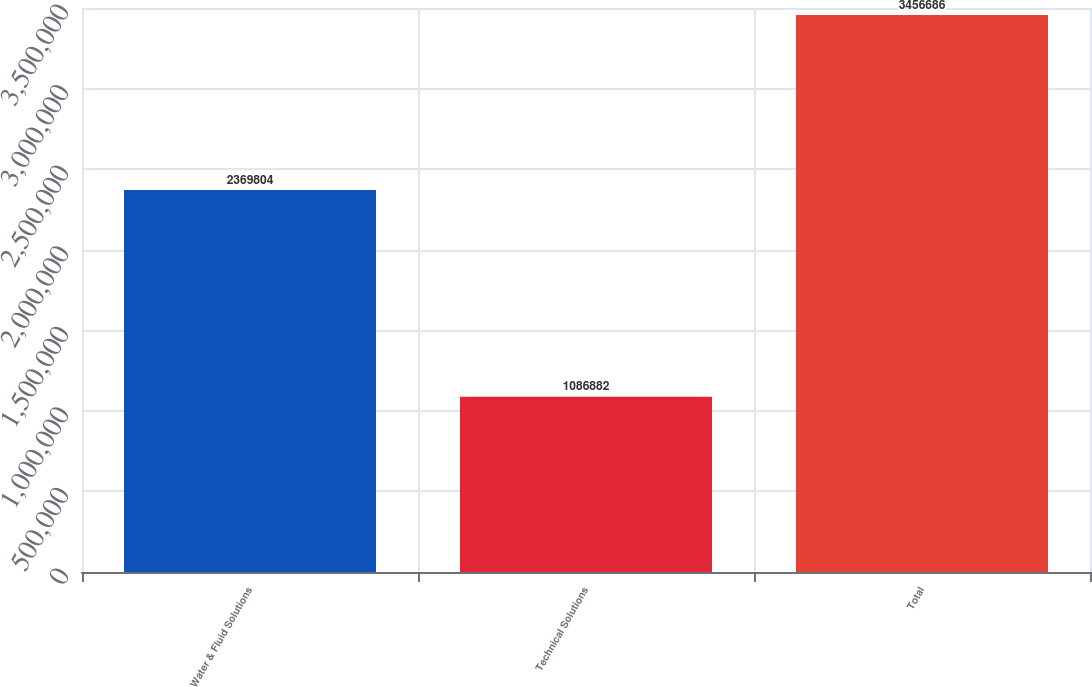Convert chart to OTSL. <chart><loc_0><loc_0><loc_500><loc_500><bar_chart><fcel>Water & Fluid Solutions<fcel>Technical Solutions<fcel>Total<nl><fcel>2.3698e+06<fcel>1.08688e+06<fcel>3.45669e+06<nl></chart> 